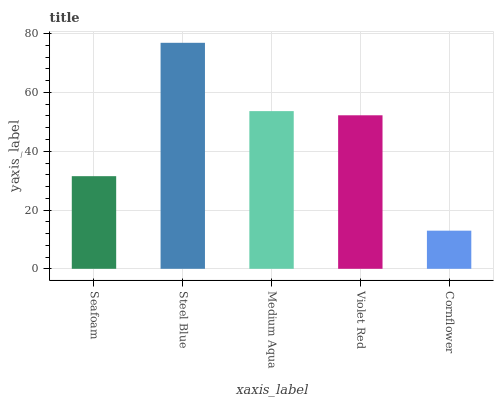Is Cornflower the minimum?
Answer yes or no. Yes. Is Steel Blue the maximum?
Answer yes or no. Yes. Is Medium Aqua the minimum?
Answer yes or no. No. Is Medium Aqua the maximum?
Answer yes or no. No. Is Steel Blue greater than Medium Aqua?
Answer yes or no. Yes. Is Medium Aqua less than Steel Blue?
Answer yes or no. Yes. Is Medium Aqua greater than Steel Blue?
Answer yes or no. No. Is Steel Blue less than Medium Aqua?
Answer yes or no. No. Is Violet Red the high median?
Answer yes or no. Yes. Is Violet Red the low median?
Answer yes or no. Yes. Is Seafoam the high median?
Answer yes or no. No. Is Cornflower the low median?
Answer yes or no. No. 